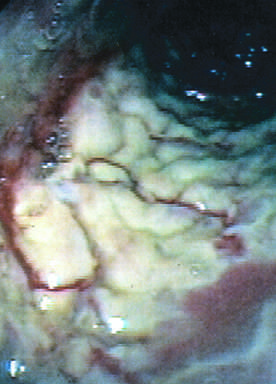what is coated by tan pseudomembranes composed of neutrophils, dead epithelial cells, and inflammatory debris endoscopic view?
Answer the question using a single word or phrase. The colon 